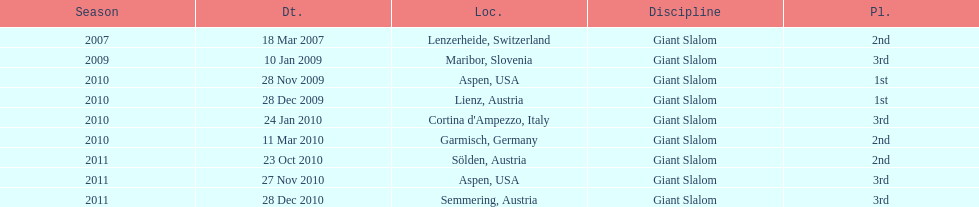How many races were in 2010? 5. 